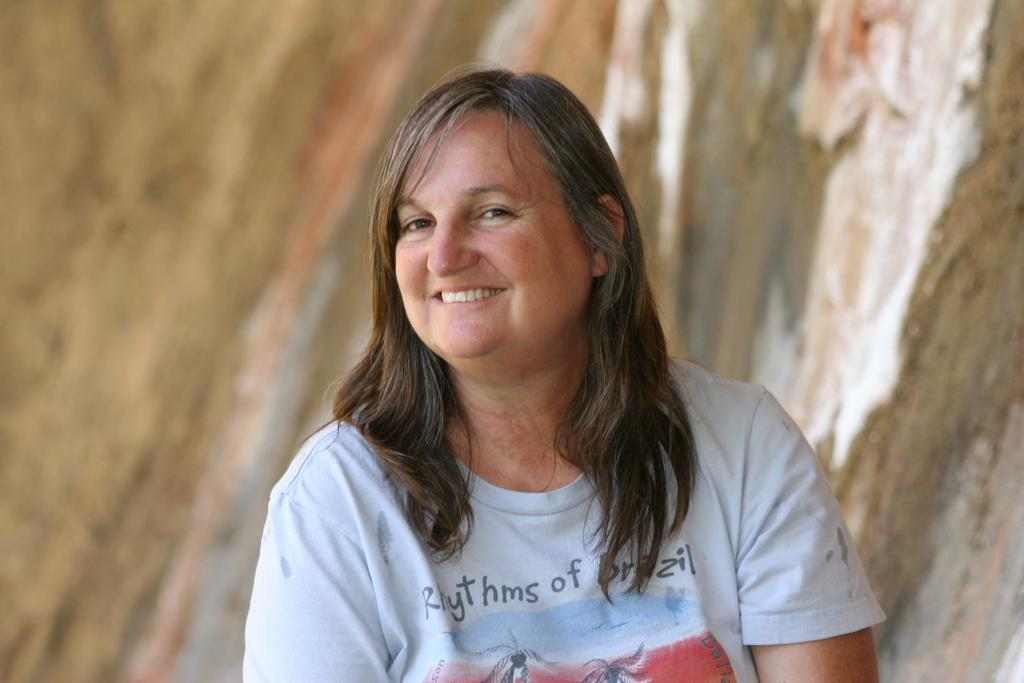Who or what is present in the image? There is a person in the image. What is the person wearing? The person is wearing a white shirt. What colors can be seen in the background of the image? The background of the image is in brown and white colors. What type of song is the yak singing in the image? There is no yak or song present in the image. 